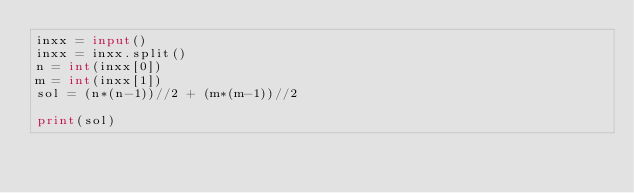<code> <loc_0><loc_0><loc_500><loc_500><_Python_>inxx = input()
inxx = inxx.split()
n = int(inxx[0])
m = int(inxx[1])
sol = (n*(n-1))//2 + (m*(m-1))//2

print(sol)</code> 